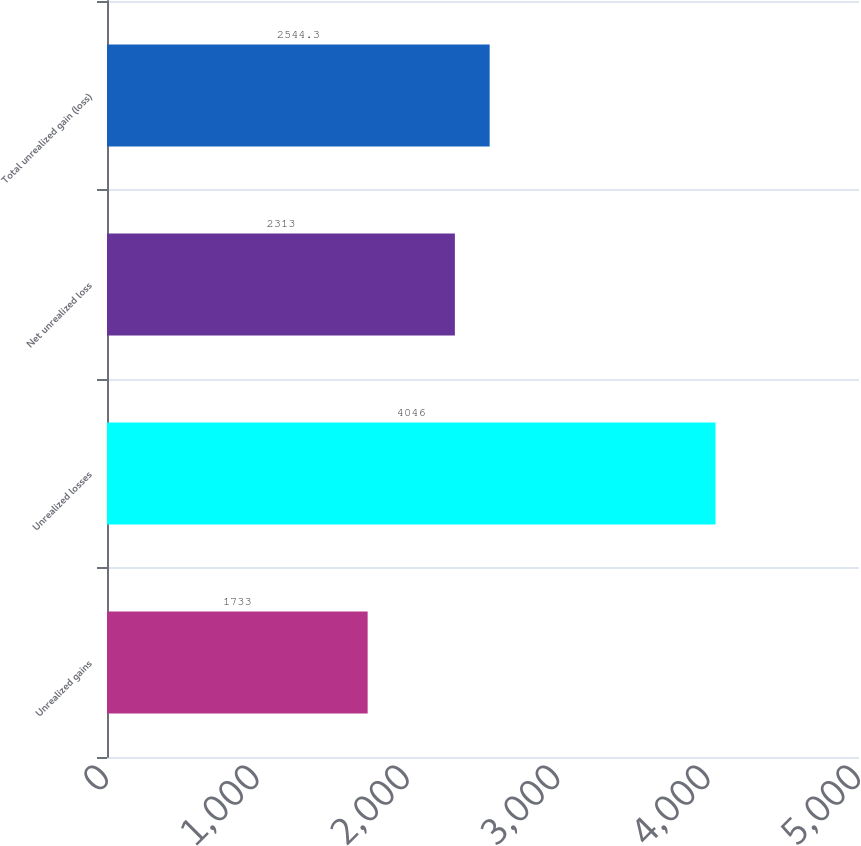Convert chart to OTSL. <chart><loc_0><loc_0><loc_500><loc_500><bar_chart><fcel>Unrealized gains<fcel>Unrealized losses<fcel>Net unrealized loss<fcel>Total unrealized gain (loss)<nl><fcel>1733<fcel>4046<fcel>2313<fcel>2544.3<nl></chart> 